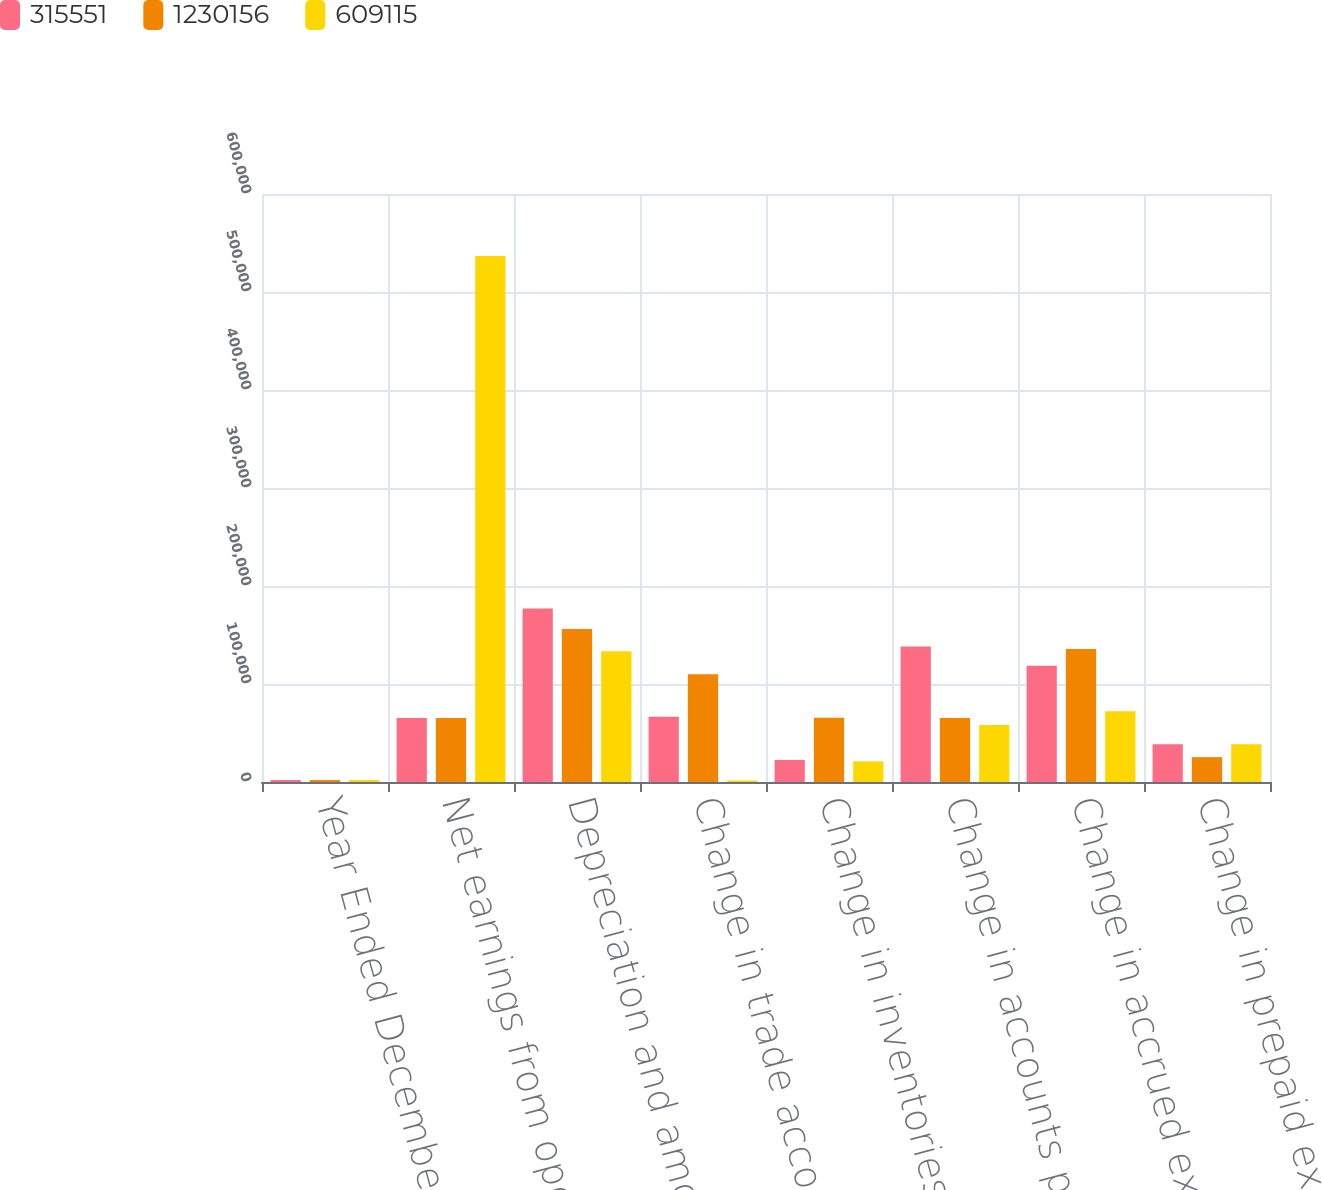Convert chart to OTSL. <chart><loc_0><loc_0><loc_500><loc_500><stacked_bar_chart><ecel><fcel>Year Ended December 31 (in<fcel>Net earnings from operations<fcel>Depreciation and amortization<fcel>Change in trade accounts<fcel>Change in inventories<fcel>Change in accounts payable<fcel>Change in accrued expenses and<fcel>Change in prepaid expenses and<nl><fcel>315551<fcel>2005<fcel>65421.5<fcel>176972<fcel>66611<fcel>22478<fcel>138144<fcel>118605<fcel>38631<nl><fcel>1.23016e+06<fcel>2004<fcel>65421.5<fcel>156128<fcel>110007<fcel>65528<fcel>65315<fcel>135616<fcel>25364<nl><fcel>609115<fcel>2003<fcel>536834<fcel>133436<fcel>1505<fcel>21061<fcel>58209<fcel>72097<fcel>38402<nl></chart> 